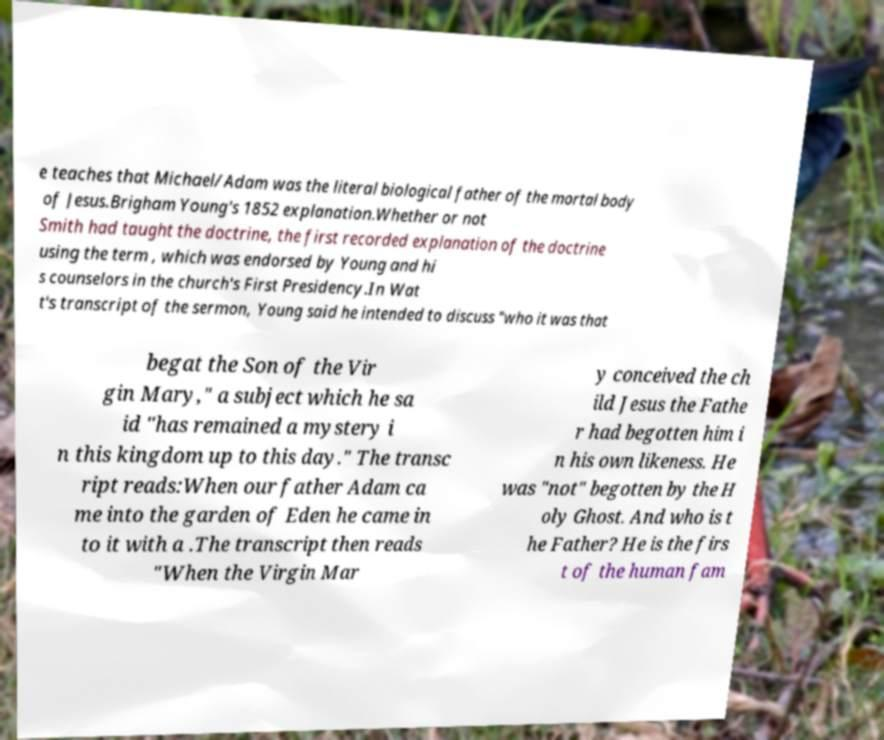For documentation purposes, I need the text within this image transcribed. Could you provide that? e teaches that Michael/Adam was the literal biological father of the mortal body of Jesus.Brigham Young's 1852 explanation.Whether or not Smith had taught the doctrine, the first recorded explanation of the doctrine using the term , which was endorsed by Young and hi s counselors in the church's First Presidency.In Wat t's transcript of the sermon, Young said he intended to discuss "who it was that begat the Son of the Vir gin Mary," a subject which he sa id "has remained a mystery i n this kingdom up to this day." The transc ript reads:When our father Adam ca me into the garden of Eden he came in to it with a .The transcript then reads "When the Virgin Mar y conceived the ch ild Jesus the Fathe r had begotten him i n his own likeness. He was "not" begotten by the H oly Ghost. And who is t he Father? He is the firs t of the human fam 